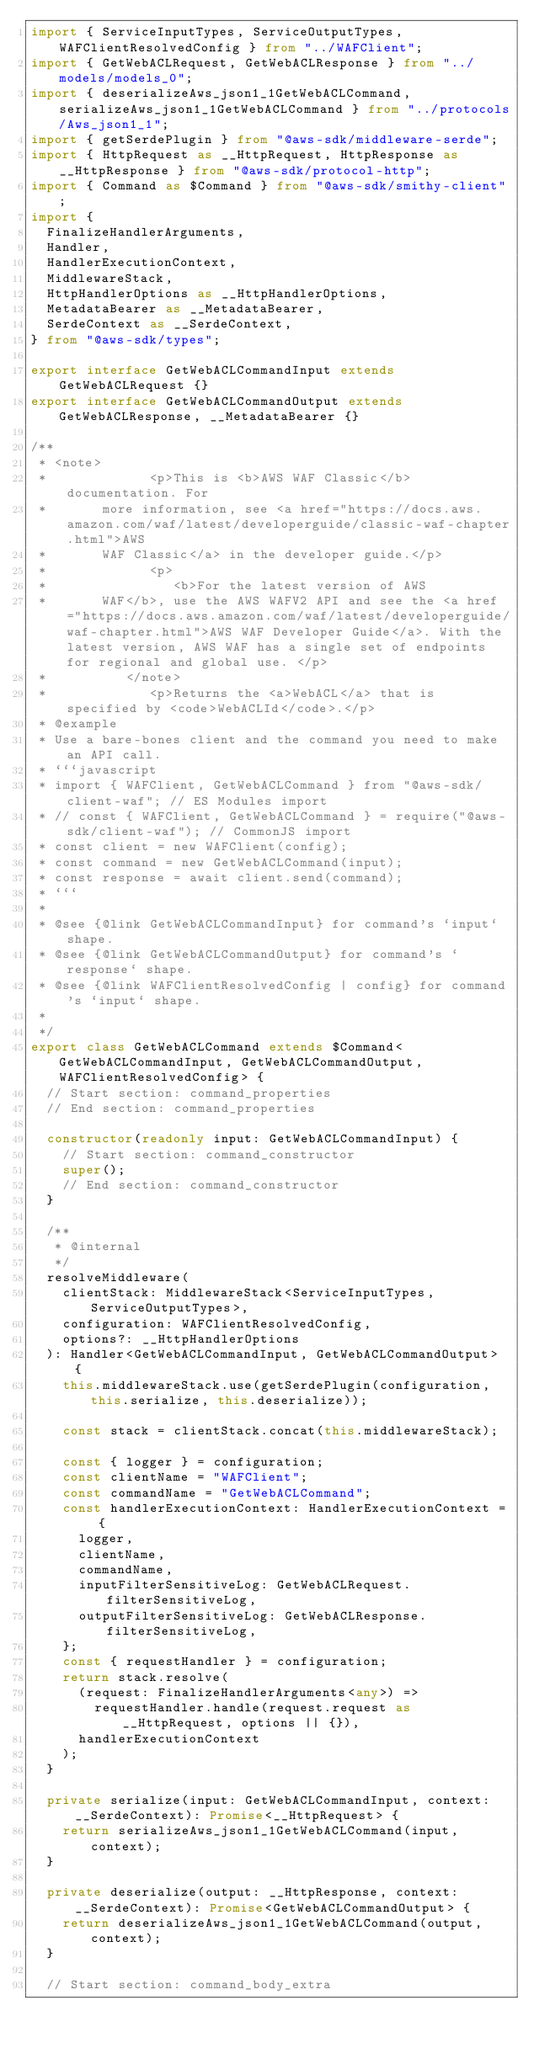<code> <loc_0><loc_0><loc_500><loc_500><_TypeScript_>import { ServiceInputTypes, ServiceOutputTypes, WAFClientResolvedConfig } from "../WAFClient";
import { GetWebACLRequest, GetWebACLResponse } from "../models/models_0";
import { deserializeAws_json1_1GetWebACLCommand, serializeAws_json1_1GetWebACLCommand } from "../protocols/Aws_json1_1";
import { getSerdePlugin } from "@aws-sdk/middleware-serde";
import { HttpRequest as __HttpRequest, HttpResponse as __HttpResponse } from "@aws-sdk/protocol-http";
import { Command as $Command } from "@aws-sdk/smithy-client";
import {
  FinalizeHandlerArguments,
  Handler,
  HandlerExecutionContext,
  MiddlewareStack,
  HttpHandlerOptions as __HttpHandlerOptions,
  MetadataBearer as __MetadataBearer,
  SerdeContext as __SerdeContext,
} from "@aws-sdk/types";

export interface GetWebACLCommandInput extends GetWebACLRequest {}
export interface GetWebACLCommandOutput extends GetWebACLResponse, __MetadataBearer {}

/**
 * <note>
 *             <p>This is <b>AWS WAF Classic</b> documentation. For
 *       more information, see <a href="https://docs.aws.amazon.com/waf/latest/developerguide/classic-waf-chapter.html">AWS
 *       WAF Classic</a> in the developer guide.</p>
 *             <p>
 *                <b>For the latest version of AWS
 *       WAF</b>, use the AWS WAFV2 API and see the <a href="https://docs.aws.amazon.com/waf/latest/developerguide/waf-chapter.html">AWS WAF Developer Guide</a>. With the latest version, AWS WAF has a single set of endpoints for regional and global use. </p>
 *          </note>
 * 		       <p>Returns the <a>WebACL</a> that is specified by <code>WebACLId</code>.</p>
 * @example
 * Use a bare-bones client and the command you need to make an API call.
 * ```javascript
 * import { WAFClient, GetWebACLCommand } from "@aws-sdk/client-waf"; // ES Modules import
 * // const { WAFClient, GetWebACLCommand } = require("@aws-sdk/client-waf"); // CommonJS import
 * const client = new WAFClient(config);
 * const command = new GetWebACLCommand(input);
 * const response = await client.send(command);
 * ```
 *
 * @see {@link GetWebACLCommandInput} for command's `input` shape.
 * @see {@link GetWebACLCommandOutput} for command's `response` shape.
 * @see {@link WAFClientResolvedConfig | config} for command's `input` shape.
 *
 */
export class GetWebACLCommand extends $Command<GetWebACLCommandInput, GetWebACLCommandOutput, WAFClientResolvedConfig> {
  // Start section: command_properties
  // End section: command_properties

  constructor(readonly input: GetWebACLCommandInput) {
    // Start section: command_constructor
    super();
    // End section: command_constructor
  }

  /**
   * @internal
   */
  resolveMiddleware(
    clientStack: MiddlewareStack<ServiceInputTypes, ServiceOutputTypes>,
    configuration: WAFClientResolvedConfig,
    options?: __HttpHandlerOptions
  ): Handler<GetWebACLCommandInput, GetWebACLCommandOutput> {
    this.middlewareStack.use(getSerdePlugin(configuration, this.serialize, this.deserialize));

    const stack = clientStack.concat(this.middlewareStack);

    const { logger } = configuration;
    const clientName = "WAFClient";
    const commandName = "GetWebACLCommand";
    const handlerExecutionContext: HandlerExecutionContext = {
      logger,
      clientName,
      commandName,
      inputFilterSensitiveLog: GetWebACLRequest.filterSensitiveLog,
      outputFilterSensitiveLog: GetWebACLResponse.filterSensitiveLog,
    };
    const { requestHandler } = configuration;
    return stack.resolve(
      (request: FinalizeHandlerArguments<any>) =>
        requestHandler.handle(request.request as __HttpRequest, options || {}),
      handlerExecutionContext
    );
  }

  private serialize(input: GetWebACLCommandInput, context: __SerdeContext): Promise<__HttpRequest> {
    return serializeAws_json1_1GetWebACLCommand(input, context);
  }

  private deserialize(output: __HttpResponse, context: __SerdeContext): Promise<GetWebACLCommandOutput> {
    return deserializeAws_json1_1GetWebACLCommand(output, context);
  }

  // Start section: command_body_extra</code> 